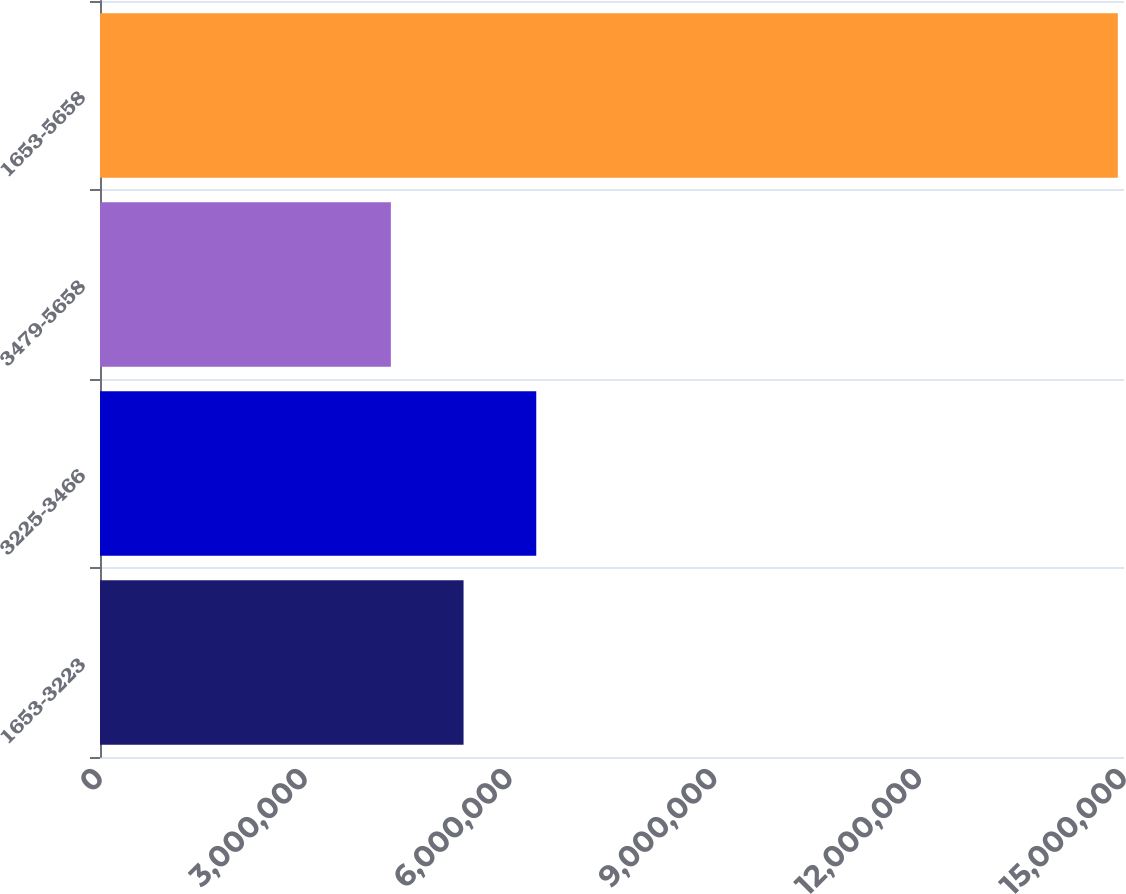<chart> <loc_0><loc_0><loc_500><loc_500><bar_chart><fcel>1653-3223<fcel>3225-3466<fcel>3479-5658<fcel>1653-5658<nl><fcel>5.32547e+06<fcel>6.39037e+06<fcel>4.26058e+06<fcel>1.49095e+07<nl></chart> 